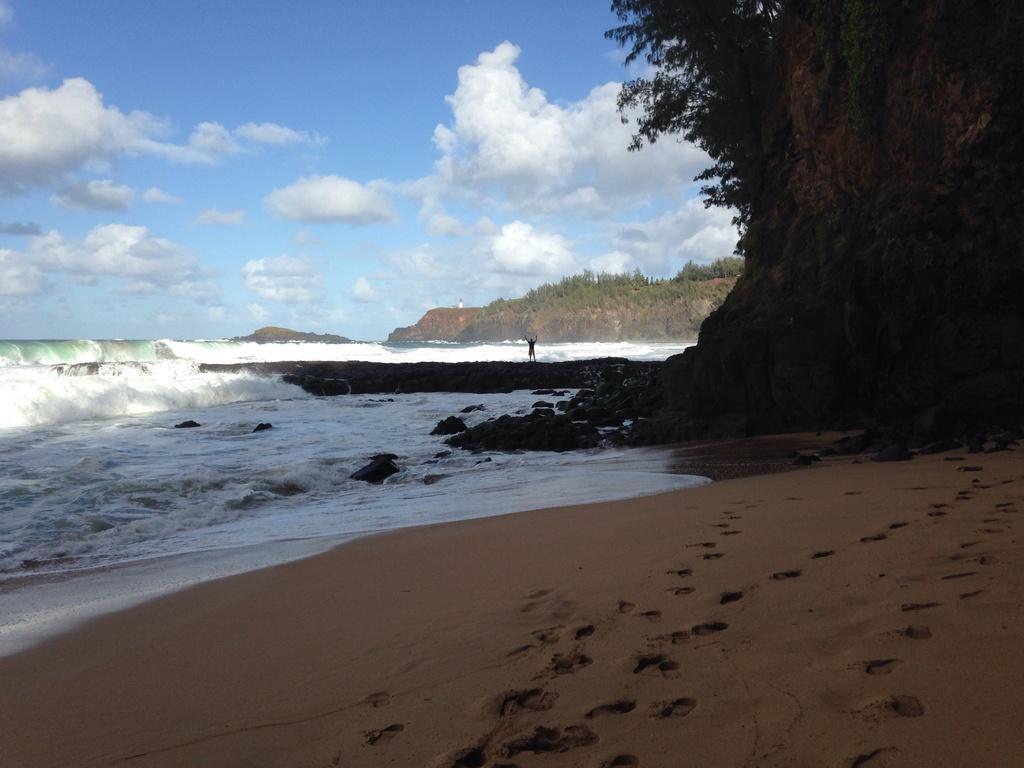Can you describe this image briefly? In this image we can see a large water and a person standing on the sea shore. On the right side we can see some trees, a bark of the tree and the mountains. On the backside we can see the sky which looks cloudy. On the bottom of the image we can see some footprints on the sand. 